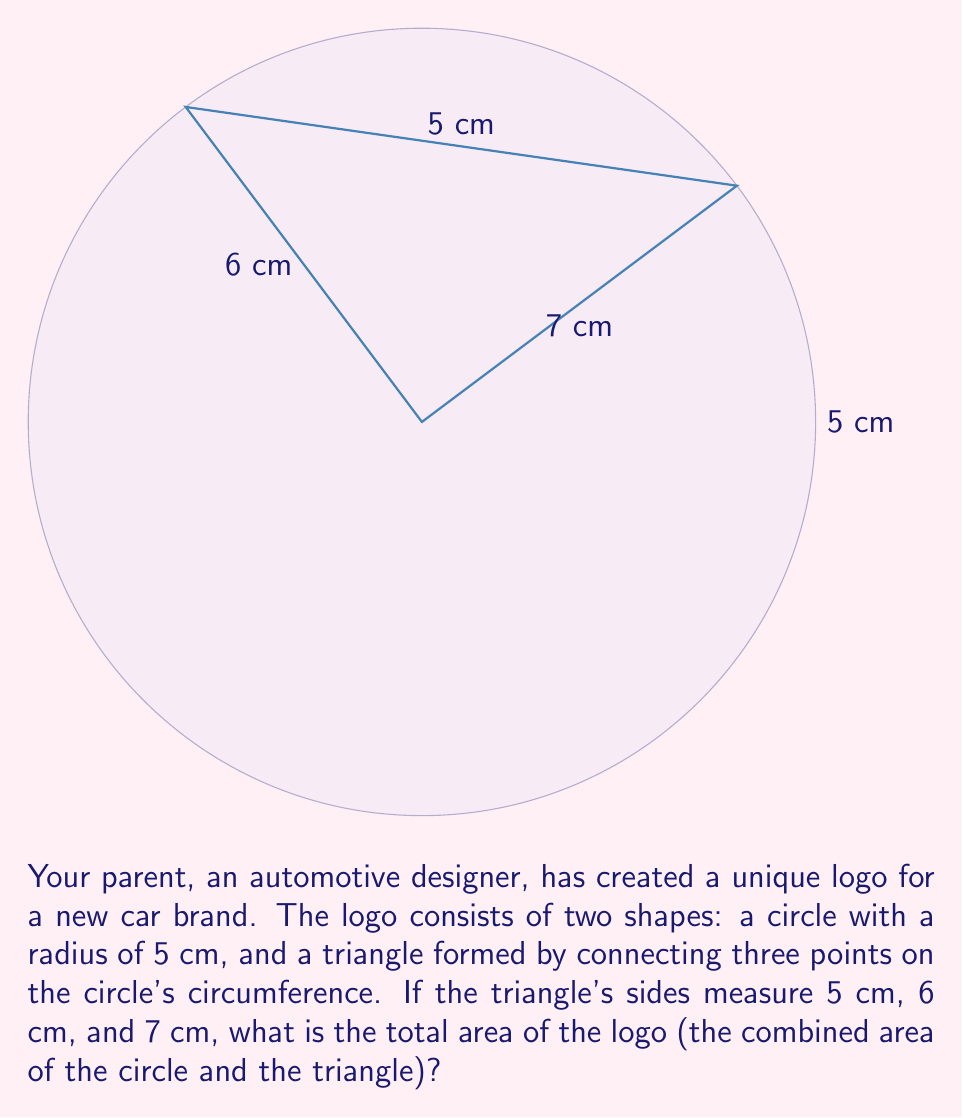Help me with this question. Let's break this problem into two parts: calculating the area of the circle and the area of the triangle.

1. Area of the circle:
   The formula for the area of a circle is $A = \pi r^2$
   With a radius of 5 cm, we get:
   $A_{circle} = \pi (5 \text{ cm})^2 = 25\pi \text{ cm}^2$

2. Area of the triangle:
   We can use Heron's formula to calculate the area of the triangle.
   Heron's formula states: $A = \sqrt{s(s-a)(s-b)(s-c)}$
   Where $s$ is the semi-perimeter: $s = \frac{a+b+c}{2}$

   $s = \frac{5 \text{ cm} + 6 \text{ cm} + 7 \text{ cm}}{2} = 9 \text{ cm}$

   Now we can apply Heron's formula:
   $$\begin{align}
   A_{triangle} &= \sqrt{9(9-5)(9-6)(9-7)} \\
   &= \sqrt{9 \cdot 4 \cdot 3 \cdot 2} \\
   &= \sqrt{216} \\
   &= 6\sqrt{6} \text{ cm}^2
   \end{align}$$

3. Total area of the logo:
   $A_{total} = A_{circle} + A_{triangle}$
   $A_{total} = 25\pi \text{ cm}^2 + 6\sqrt{6} \text{ cm}^2$

Therefore, the total area of the logo is $25\pi + 6\sqrt{6} \text{ cm}^2$.
Answer: $25\pi + 6\sqrt{6} \text{ cm}^2$ 